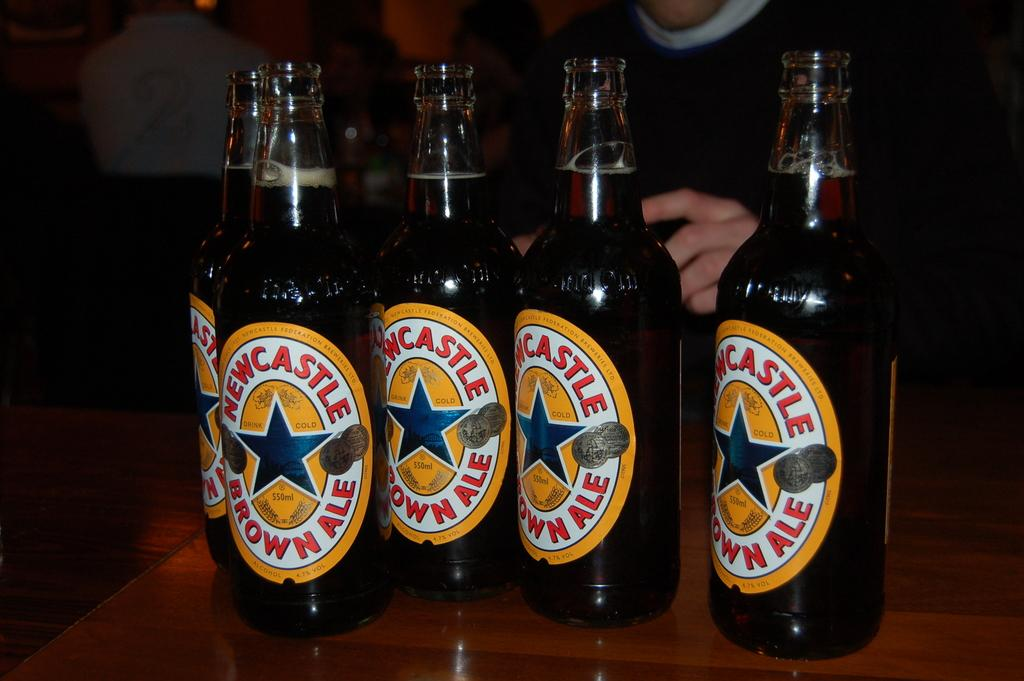<image>
Write a terse but informative summary of the picture. Five bottles of Newcastle Brown Ale stand on a table. 